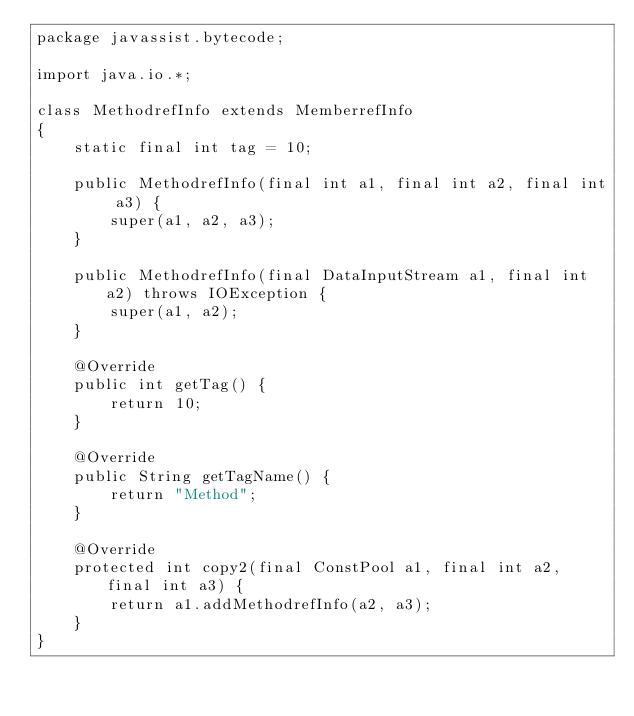<code> <loc_0><loc_0><loc_500><loc_500><_Java_>package javassist.bytecode;

import java.io.*;

class MethodrefInfo extends MemberrefInfo
{
    static final int tag = 10;
    
    public MethodrefInfo(final int a1, final int a2, final int a3) {
        super(a1, a2, a3);
    }
    
    public MethodrefInfo(final DataInputStream a1, final int a2) throws IOException {
        super(a1, a2);
    }
    
    @Override
    public int getTag() {
        return 10;
    }
    
    @Override
    public String getTagName() {
        return "Method";
    }
    
    @Override
    protected int copy2(final ConstPool a1, final int a2, final int a3) {
        return a1.addMethodrefInfo(a2, a3);
    }
}
</code> 